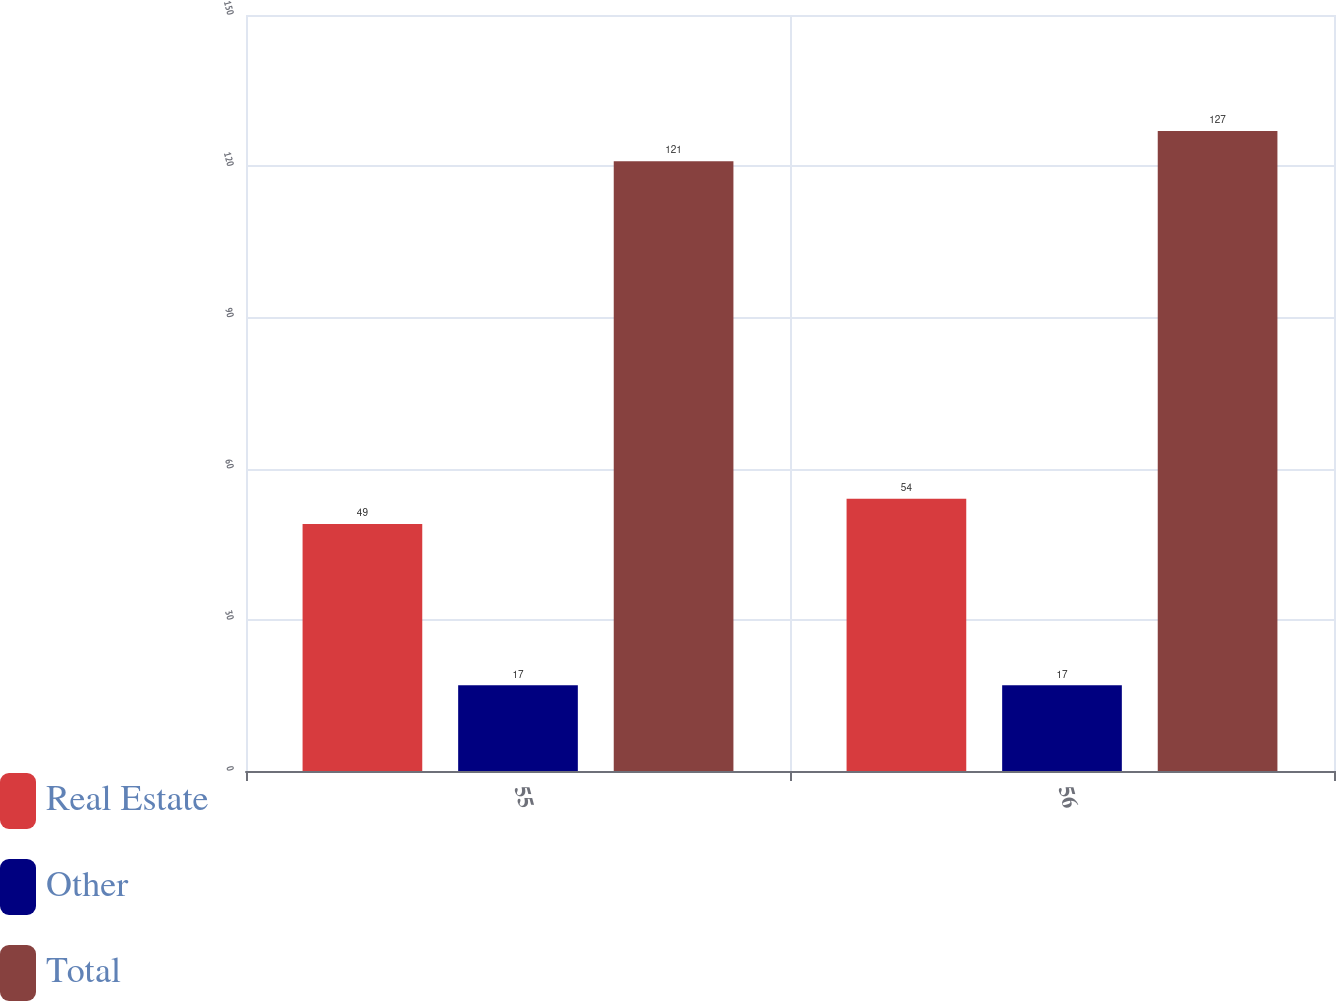Convert chart to OTSL. <chart><loc_0><loc_0><loc_500><loc_500><stacked_bar_chart><ecel><fcel>55<fcel>56<nl><fcel>Real Estate<fcel>49<fcel>54<nl><fcel>Other<fcel>17<fcel>17<nl><fcel>Total<fcel>121<fcel>127<nl></chart> 